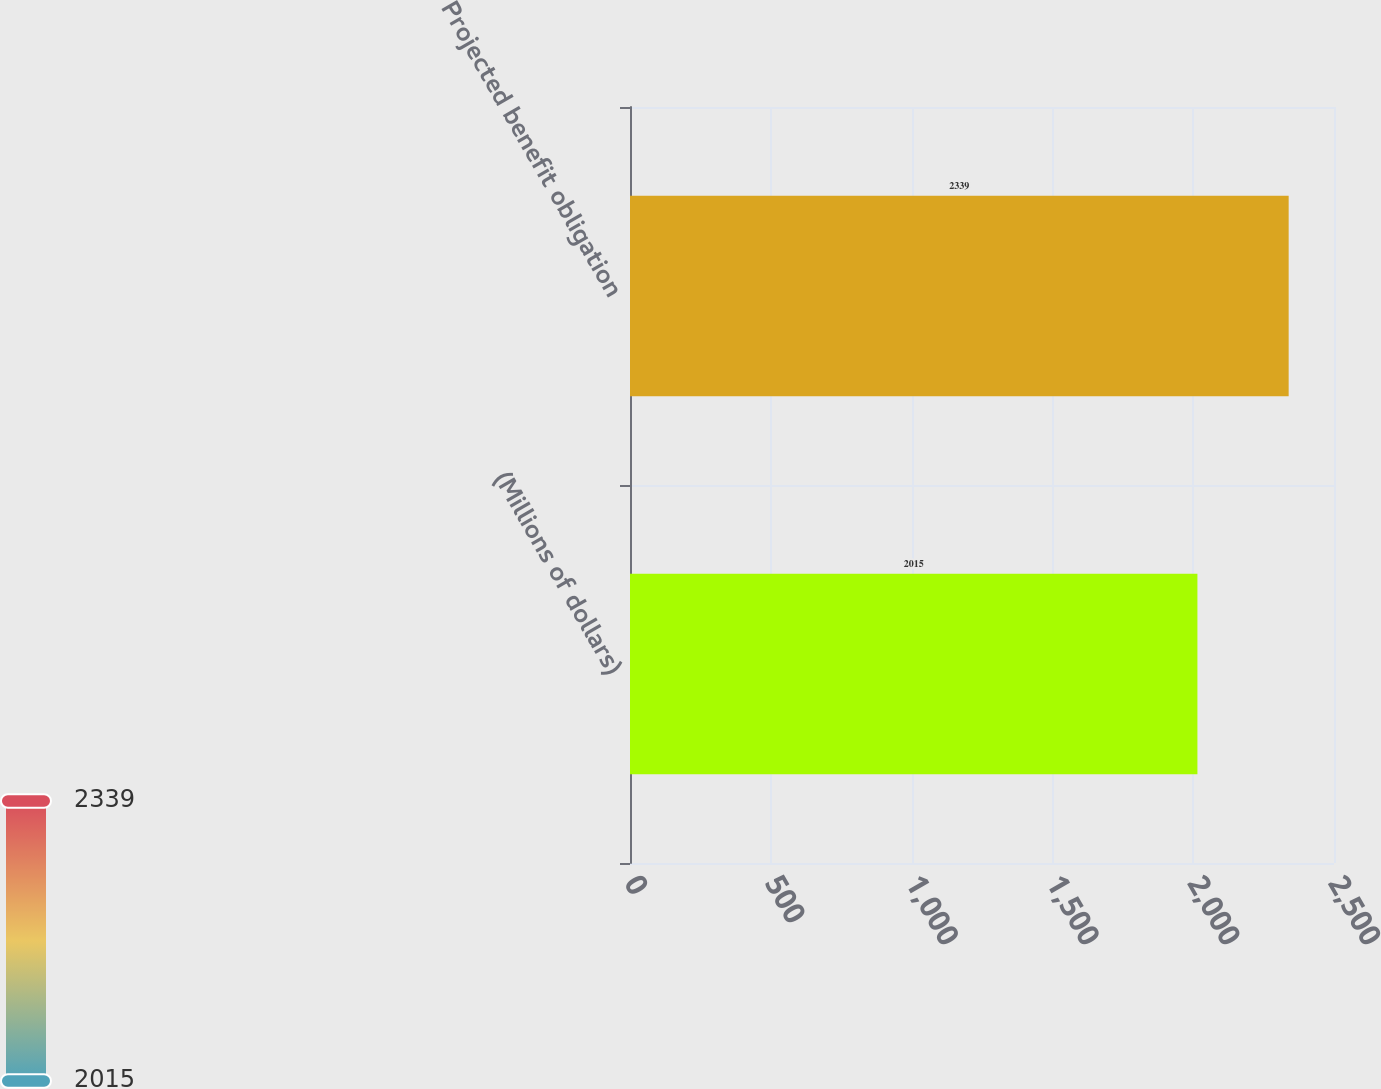Convert chart to OTSL. <chart><loc_0><loc_0><loc_500><loc_500><bar_chart><fcel>(Millions of dollars)<fcel>Projected benefit obligation<nl><fcel>2015<fcel>2339<nl></chart> 